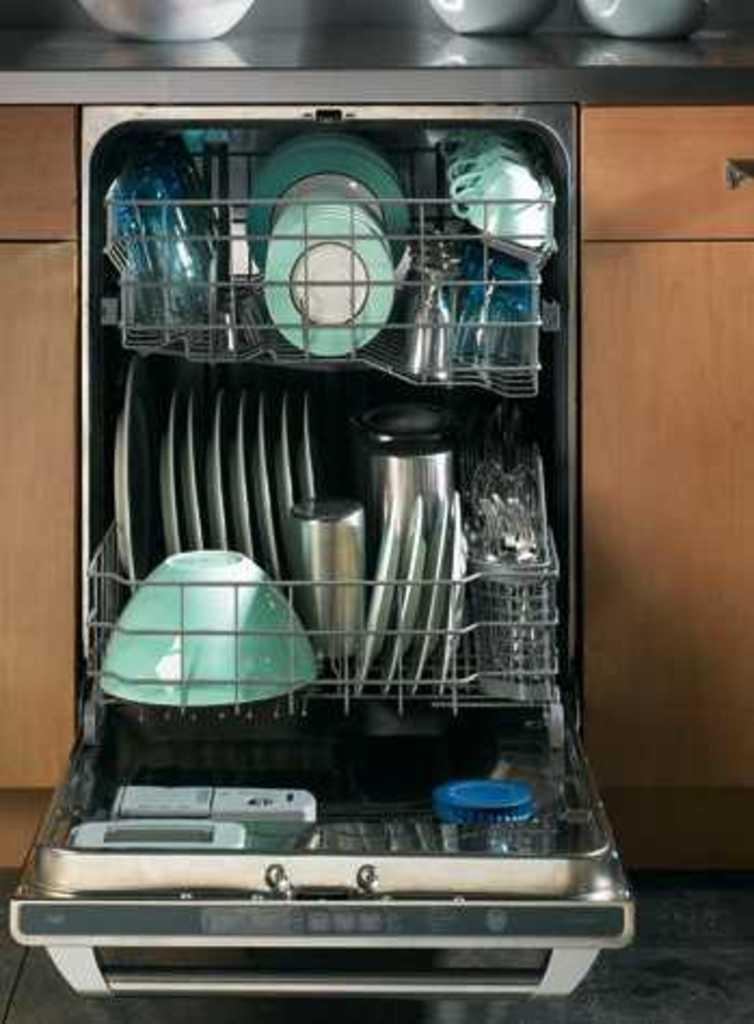What is located on the stand in the image? There is a stand with utensils in the image. What can be seen on either side of the image? There are cupboards on the left and right sides of the image. What is on the desk at the top of the image? There are bowls on a desk at the top of the image. How many corn plants are visible in the image? There are no corn plants present in the image. What type of vase is holding flowers on the desk at the top of the image? There is no vase holding flowers in the image; only bowls are present on the desk. 